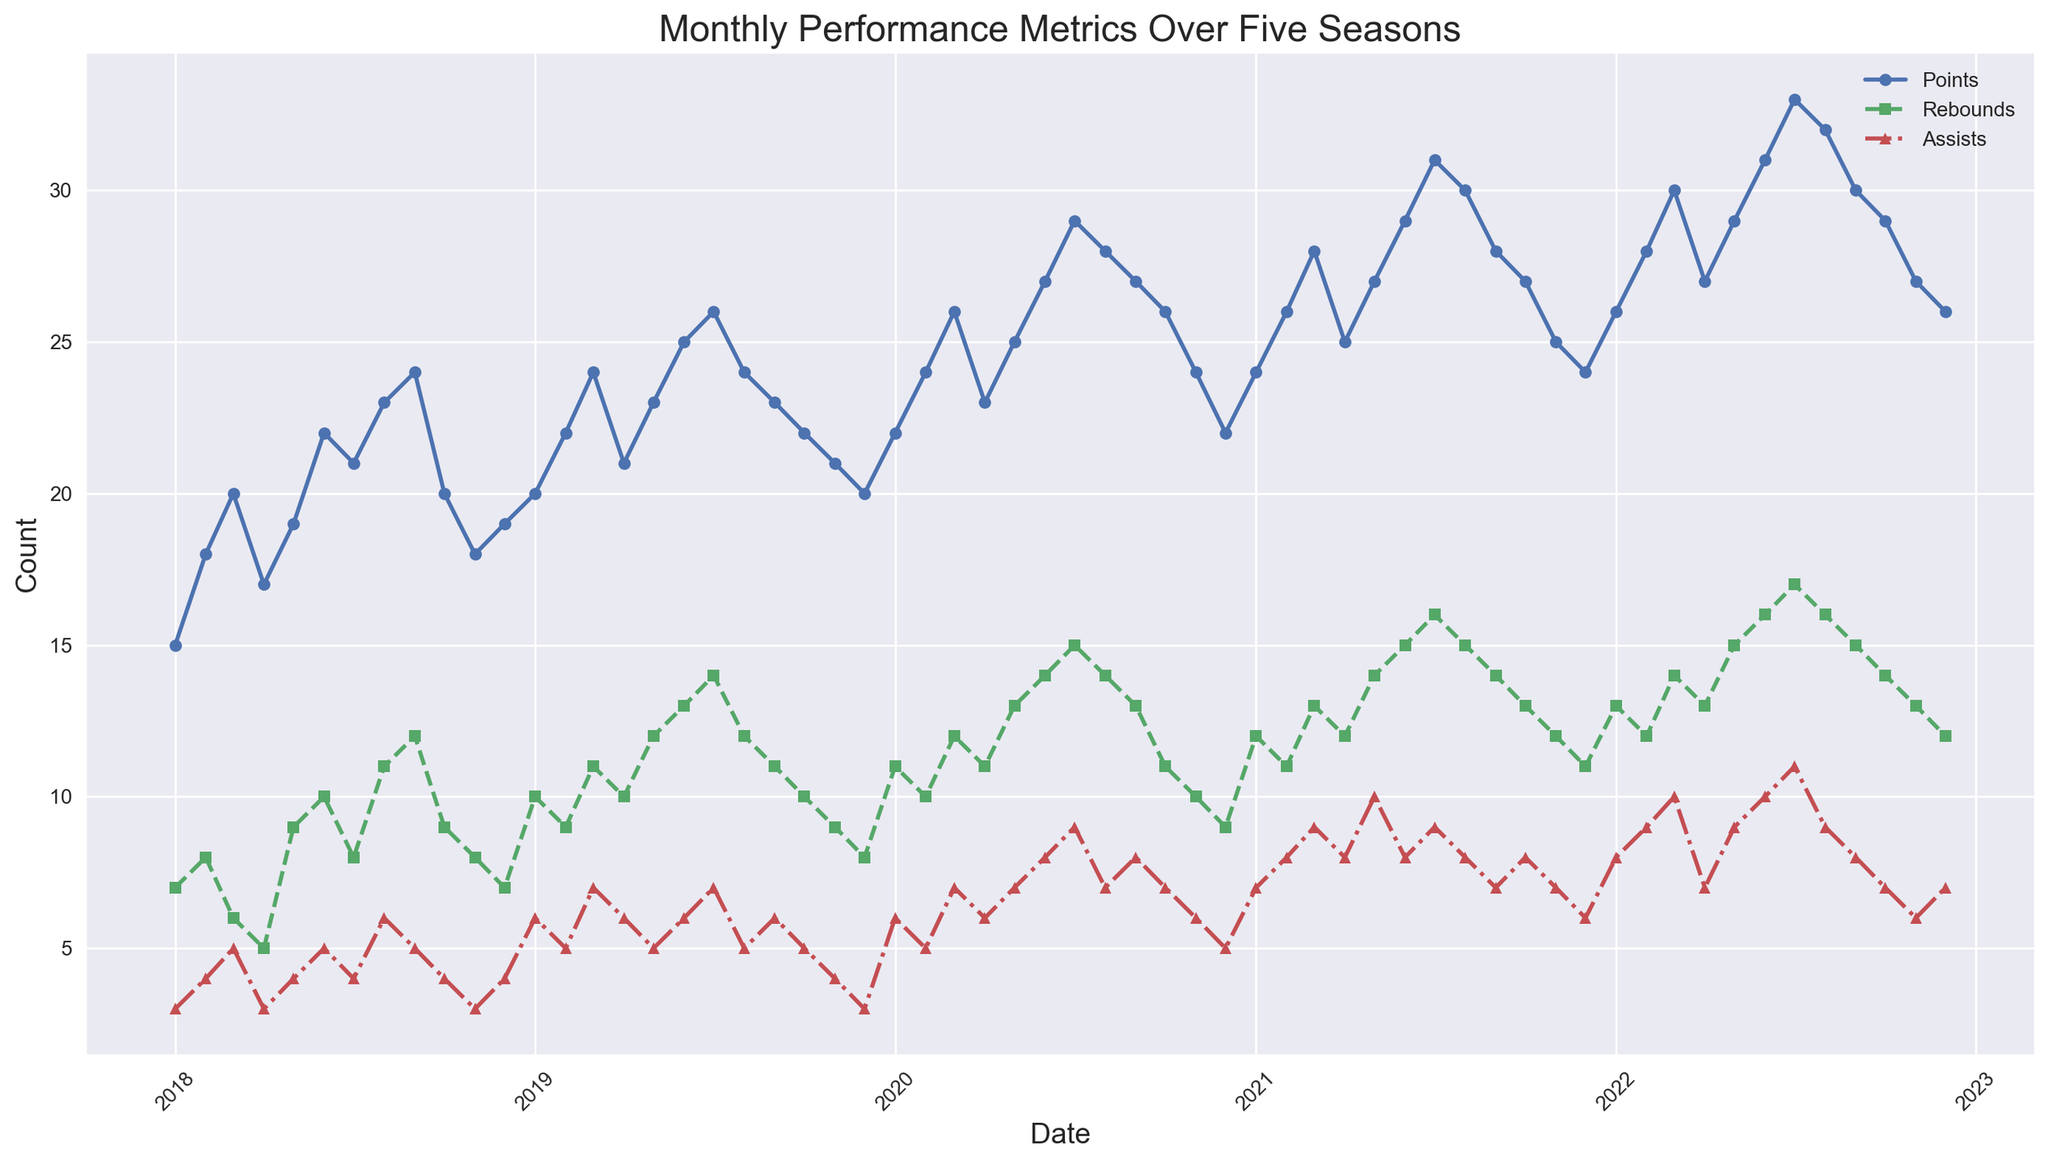How did the points scored in October 2020 compare with December 2020? Points in October 2020 were 26, while in December 2020 they were 22.
Answer: October 2020 What is the overall trend in rebounds from January to June 2022? From January to June 2022, rebounds increased from 13 to 16.
Answer: Increasing Which month showed the highest assists in 2022 and what was the value? In July 2022, assists reached their highest value at 11.
Answer: July 2022, 11 Among all the seasons, in which month and season did the highest points occur? The highest points occurred in July 2022 with a value of 33.
Answer: July 2022 From June to October 2020, how did the rebounds change and what is the overall difference? Rebounds from June (14) to October (11) 2020 decreased by 3.
Answer: Decreased by 3 How does the assists value in August 2021 compare to the one in August 2018? Assists in August 2021 were 8, compared to 6 in August 2018.
Answer: Higher in 2021 What is the average points scored in all January months across the five seasons? The points in January for the five seasons are 15, 20, 22, 24, 26. The average is (15 + 20 + 22 + 24 + 26) / 5 = 21.4
Answer: 21.4 When comparing March 2018 and March 2019, which month had a higher number of assists and by how much? March 2018 had 5 assists, while March 2019 had 7 assists. March 2019 had 2 more assists.
Answer: March 2019, 2 more What is the total number of points scored in the 2019 season? Adding all points from January to December 2019 gives: 20 + 22 + 24 + 21 + 23 + 25 + 26 + 24 + 23 + 22 + 21 + 20 = 271
Answer: 271 In which month did the rebounds surpass 10 for the first time in the 2021 season? The rebounds first surpassed 10 in January 2021 with a value of 12.
Answer: January 2021 